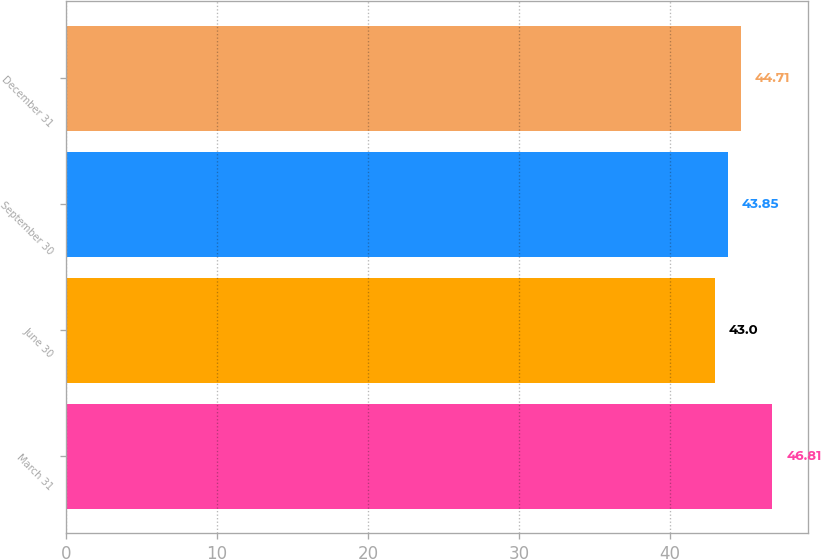Convert chart. <chart><loc_0><loc_0><loc_500><loc_500><bar_chart><fcel>March 31<fcel>June 30<fcel>September 30<fcel>December 31<nl><fcel>46.81<fcel>43<fcel>43.85<fcel>44.71<nl></chart> 